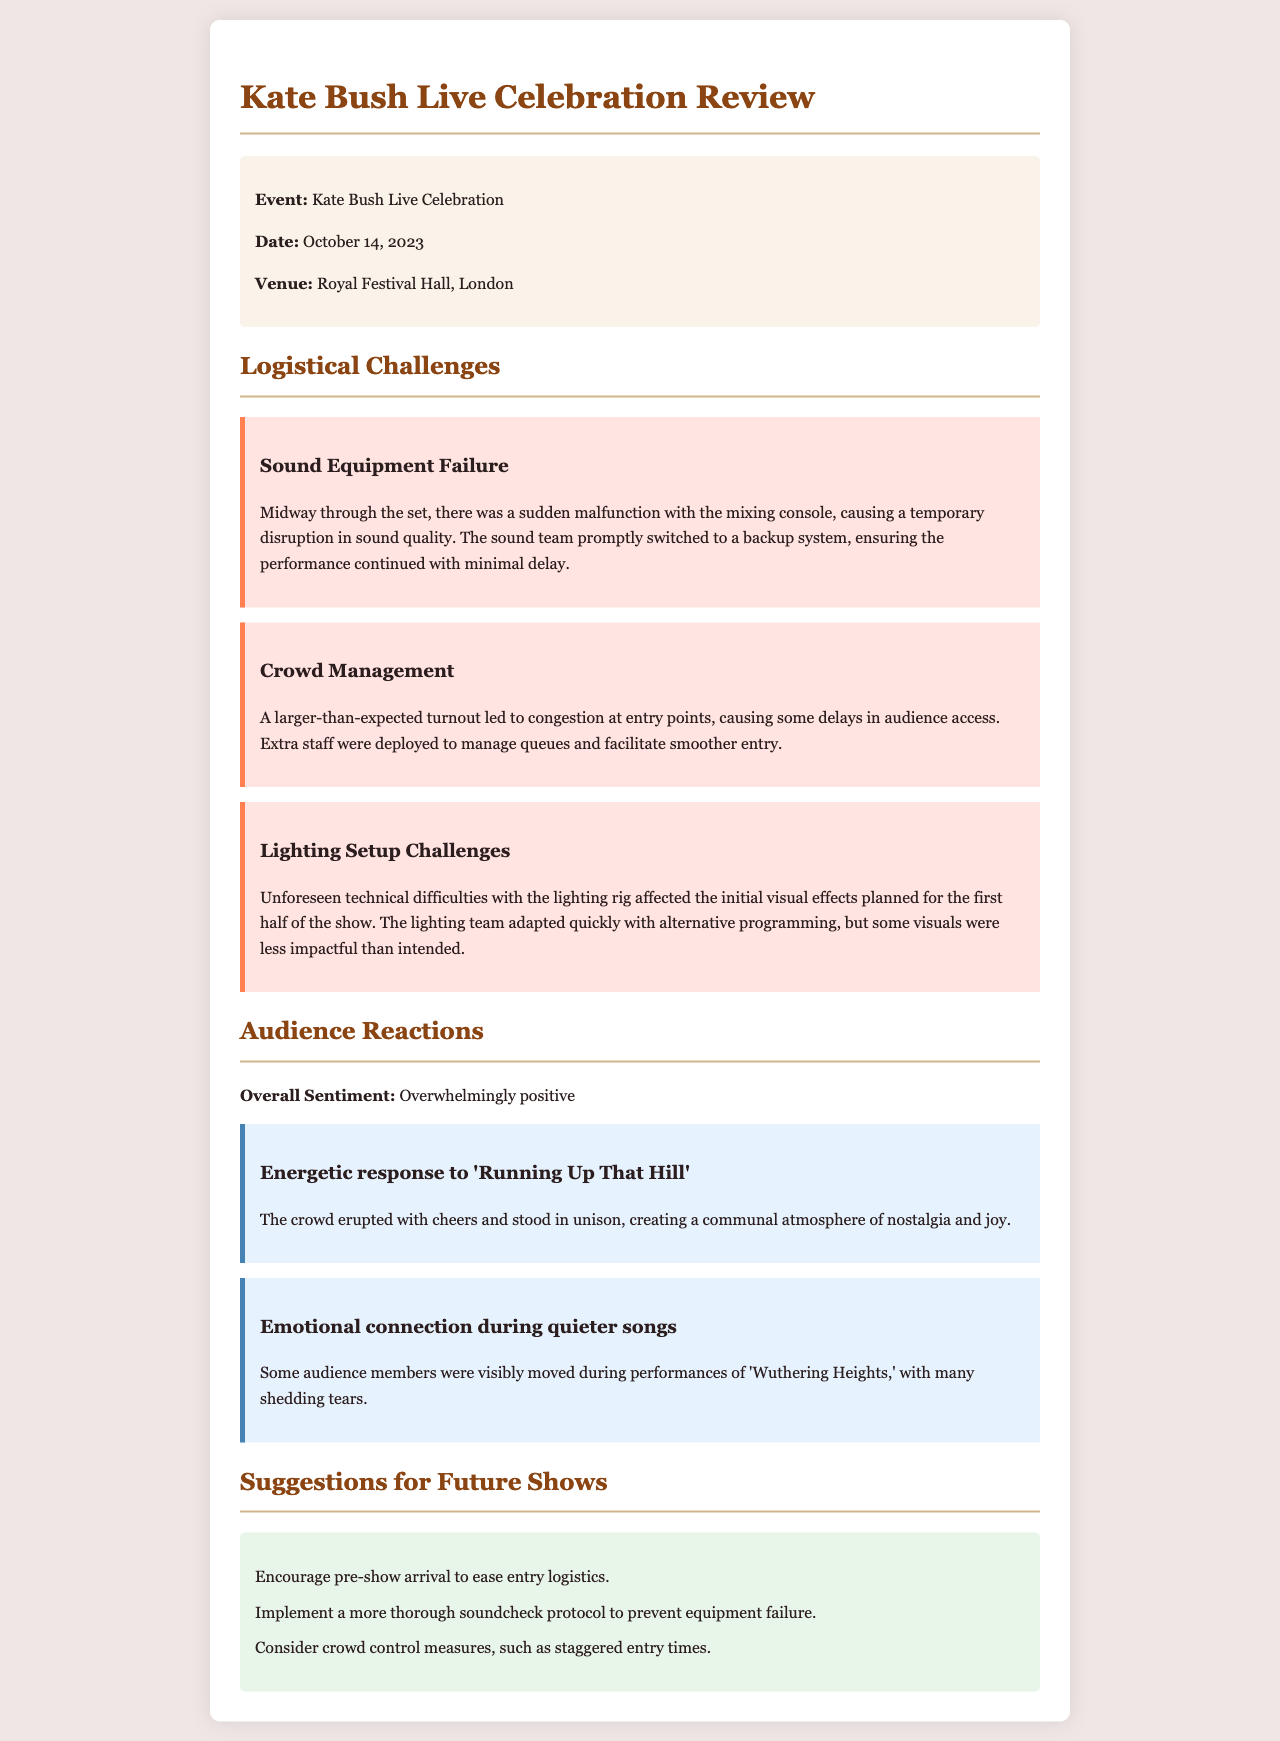what was the date of the event? The date of the event is mentioned in the document as October 14, 2023.
Answer: October 14, 2023 where was the live performance held? The venue for the live performance is specified as Royal Festival Hall, London.
Answer: Royal Festival Hall, London what was a major logistical challenge faced during the performance? The document highlights multiple challenges, one being sound equipment failure during the set.
Answer: Sound equipment failure how did the audience respond to 'Running Up That Hill'? The audience reacted with cheers and created a communal atmosphere of nostalgia and joy.
Answer: Overwhelmingly positive what is one suggestion for future shows mentioned in the document? The document lists several suggestions; one is to encourage pre-show arrival to ease entry logistics.
Answer: Encourage pre-show arrival what was the overall sentiment of the audience according to the review? The review indicates that the overall sentiment of the audience was overwhelmingly positive.
Answer: Overwhelmingly positive how did the crowd manage during unexpected turnout? The document states that extra staff were deployed to manage queues and facilitate smoother entry.
Answer: Extra staff were deployed what technical difficulty affected the visual effects? The lighting setup faced unforeseen technical difficulties affecting initial visuals planned for the show.
Answer: Lighting setup challenges 